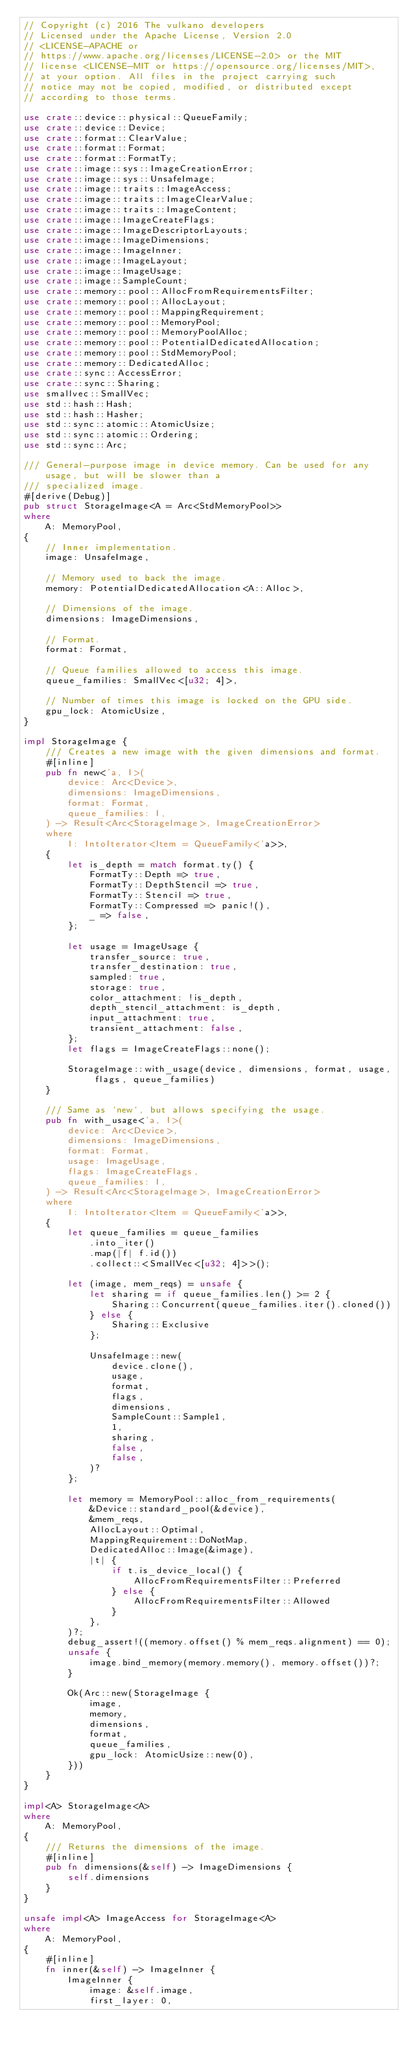Convert code to text. <code><loc_0><loc_0><loc_500><loc_500><_Rust_>// Copyright (c) 2016 The vulkano developers
// Licensed under the Apache License, Version 2.0
// <LICENSE-APACHE or
// https://www.apache.org/licenses/LICENSE-2.0> or the MIT
// license <LICENSE-MIT or https://opensource.org/licenses/MIT>,
// at your option. All files in the project carrying such
// notice may not be copied, modified, or distributed except
// according to those terms.

use crate::device::physical::QueueFamily;
use crate::device::Device;
use crate::format::ClearValue;
use crate::format::Format;
use crate::format::FormatTy;
use crate::image::sys::ImageCreationError;
use crate::image::sys::UnsafeImage;
use crate::image::traits::ImageAccess;
use crate::image::traits::ImageClearValue;
use crate::image::traits::ImageContent;
use crate::image::ImageCreateFlags;
use crate::image::ImageDescriptorLayouts;
use crate::image::ImageDimensions;
use crate::image::ImageInner;
use crate::image::ImageLayout;
use crate::image::ImageUsage;
use crate::image::SampleCount;
use crate::memory::pool::AllocFromRequirementsFilter;
use crate::memory::pool::AllocLayout;
use crate::memory::pool::MappingRequirement;
use crate::memory::pool::MemoryPool;
use crate::memory::pool::MemoryPoolAlloc;
use crate::memory::pool::PotentialDedicatedAllocation;
use crate::memory::pool::StdMemoryPool;
use crate::memory::DedicatedAlloc;
use crate::sync::AccessError;
use crate::sync::Sharing;
use smallvec::SmallVec;
use std::hash::Hash;
use std::hash::Hasher;
use std::sync::atomic::AtomicUsize;
use std::sync::atomic::Ordering;
use std::sync::Arc;

/// General-purpose image in device memory. Can be used for any usage, but will be slower than a
/// specialized image.
#[derive(Debug)]
pub struct StorageImage<A = Arc<StdMemoryPool>>
where
    A: MemoryPool,
{
    // Inner implementation.
    image: UnsafeImage,

    // Memory used to back the image.
    memory: PotentialDedicatedAllocation<A::Alloc>,

    // Dimensions of the image.
    dimensions: ImageDimensions,

    // Format.
    format: Format,

    // Queue families allowed to access this image.
    queue_families: SmallVec<[u32; 4]>,

    // Number of times this image is locked on the GPU side.
    gpu_lock: AtomicUsize,
}

impl StorageImage {
    /// Creates a new image with the given dimensions and format.
    #[inline]
    pub fn new<'a, I>(
        device: Arc<Device>,
        dimensions: ImageDimensions,
        format: Format,
        queue_families: I,
    ) -> Result<Arc<StorageImage>, ImageCreationError>
    where
        I: IntoIterator<Item = QueueFamily<'a>>,
    {
        let is_depth = match format.ty() {
            FormatTy::Depth => true,
            FormatTy::DepthStencil => true,
            FormatTy::Stencil => true,
            FormatTy::Compressed => panic!(),
            _ => false,
        };

        let usage = ImageUsage {
            transfer_source: true,
            transfer_destination: true,
            sampled: true,
            storage: true,
            color_attachment: !is_depth,
            depth_stencil_attachment: is_depth,
            input_attachment: true,
            transient_attachment: false,
        };
        let flags = ImageCreateFlags::none();

        StorageImage::with_usage(device, dimensions, format, usage, flags, queue_families)
    }

    /// Same as `new`, but allows specifying the usage.
    pub fn with_usage<'a, I>(
        device: Arc<Device>,
        dimensions: ImageDimensions,
        format: Format,
        usage: ImageUsage,
        flags: ImageCreateFlags,
        queue_families: I,
    ) -> Result<Arc<StorageImage>, ImageCreationError>
    where
        I: IntoIterator<Item = QueueFamily<'a>>,
    {
        let queue_families = queue_families
            .into_iter()
            .map(|f| f.id())
            .collect::<SmallVec<[u32; 4]>>();

        let (image, mem_reqs) = unsafe {
            let sharing = if queue_families.len() >= 2 {
                Sharing::Concurrent(queue_families.iter().cloned())
            } else {
                Sharing::Exclusive
            };

            UnsafeImage::new(
                device.clone(),
                usage,
                format,
                flags,
                dimensions,
                SampleCount::Sample1,
                1,
                sharing,
                false,
                false,
            )?
        };

        let memory = MemoryPool::alloc_from_requirements(
            &Device::standard_pool(&device),
            &mem_reqs,
            AllocLayout::Optimal,
            MappingRequirement::DoNotMap,
            DedicatedAlloc::Image(&image),
            |t| {
                if t.is_device_local() {
                    AllocFromRequirementsFilter::Preferred
                } else {
                    AllocFromRequirementsFilter::Allowed
                }
            },
        )?;
        debug_assert!((memory.offset() % mem_reqs.alignment) == 0);
        unsafe {
            image.bind_memory(memory.memory(), memory.offset())?;
        }

        Ok(Arc::new(StorageImage {
            image,
            memory,
            dimensions,
            format,
            queue_families,
            gpu_lock: AtomicUsize::new(0),
        }))
    }
}

impl<A> StorageImage<A>
where
    A: MemoryPool,
{
    /// Returns the dimensions of the image.
    #[inline]
    pub fn dimensions(&self) -> ImageDimensions {
        self.dimensions
    }
}

unsafe impl<A> ImageAccess for StorageImage<A>
where
    A: MemoryPool,
{
    #[inline]
    fn inner(&self) -> ImageInner {
        ImageInner {
            image: &self.image,
            first_layer: 0,</code> 